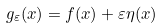Convert formula to latex. <formula><loc_0><loc_0><loc_500><loc_500>g _ { \varepsilon } ( x ) = f ( x ) + \varepsilon \eta ( x )</formula> 